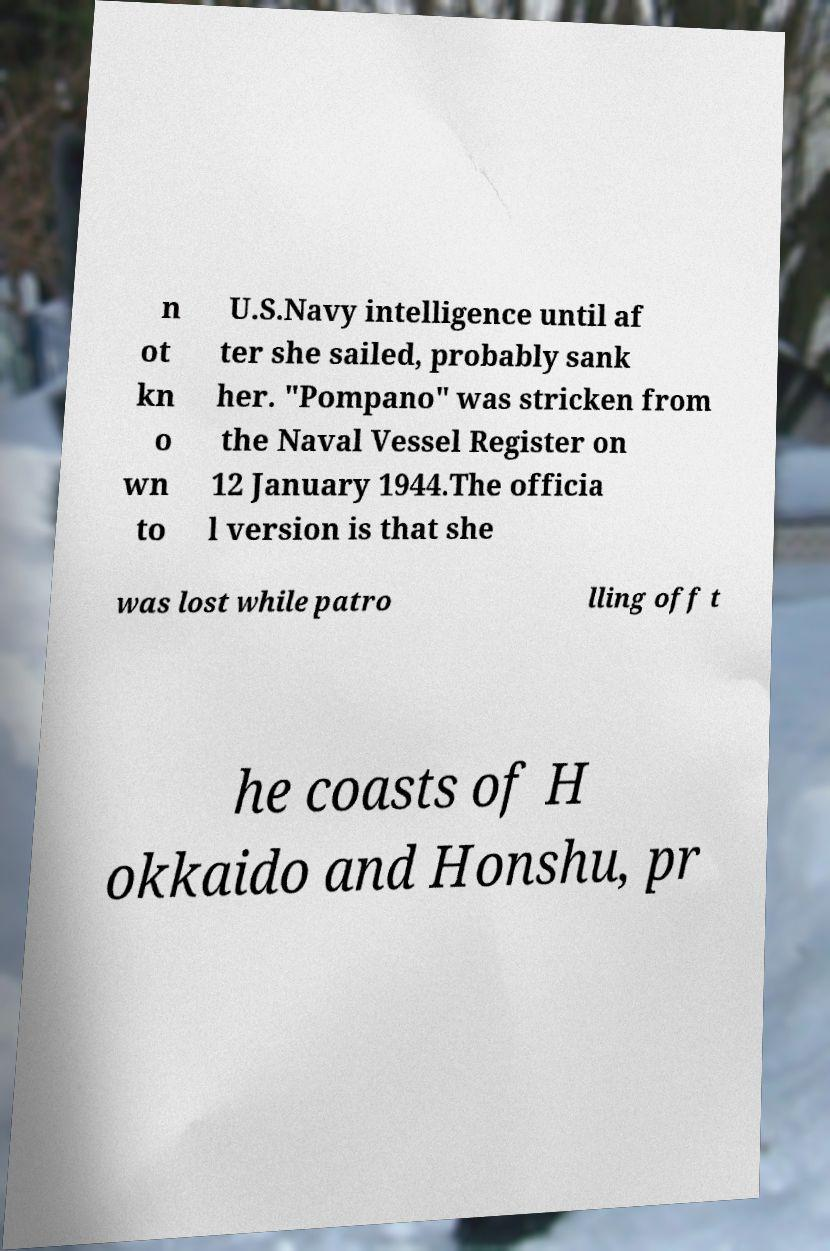Can you read and provide the text displayed in the image?This photo seems to have some interesting text. Can you extract and type it out for me? n ot kn o wn to U.S.Navy intelligence until af ter she sailed, probably sank her. "Pompano" was stricken from the Naval Vessel Register on 12 January 1944.The officia l version is that she was lost while patro lling off t he coasts of H okkaido and Honshu, pr 